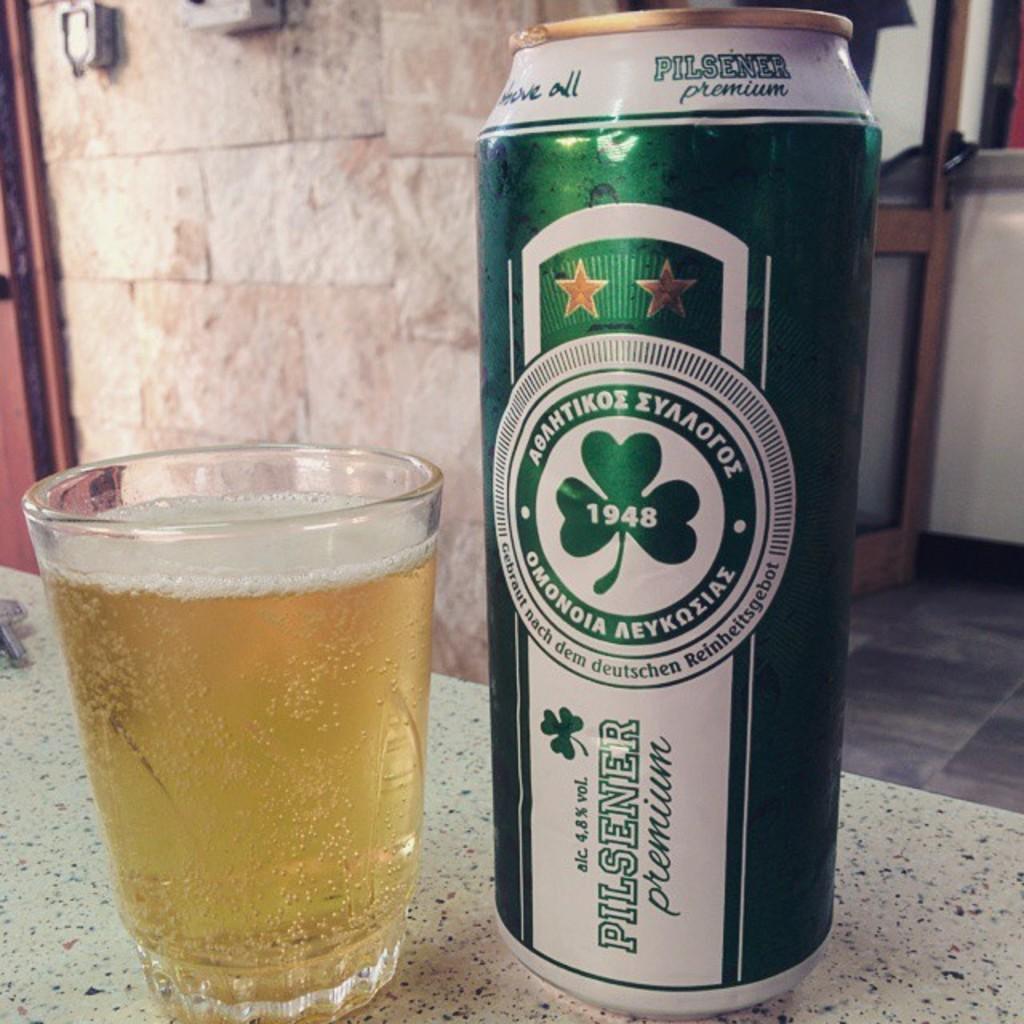Please provide a concise description of this image. In this image there is a glass and a tin on a table, in the background there is a wall for that wall there is a door. 